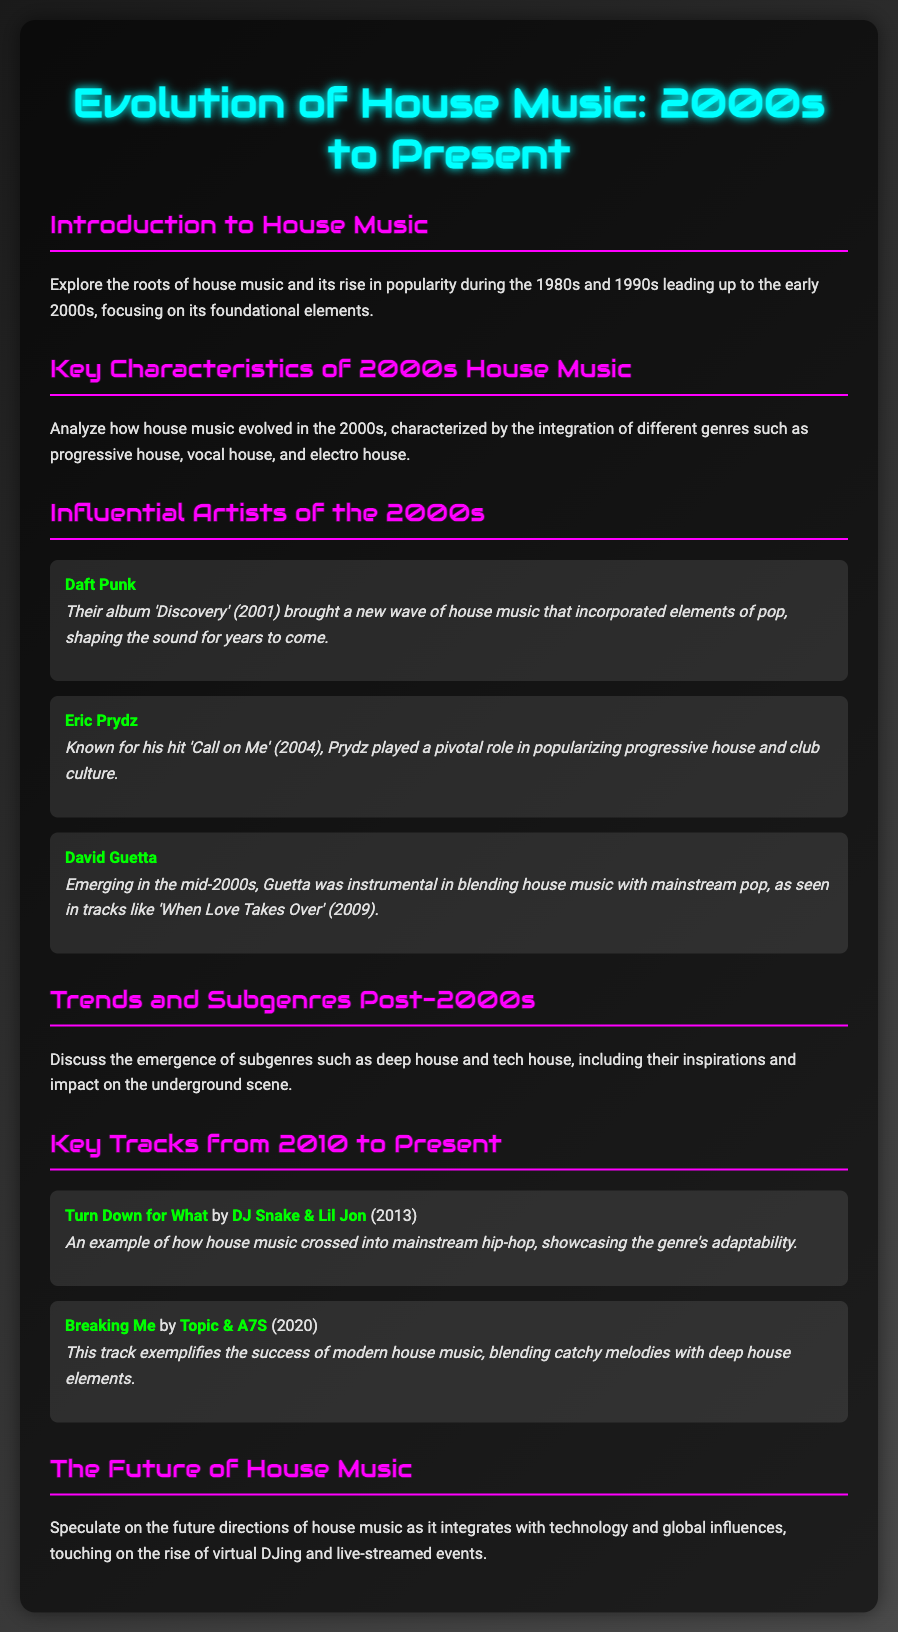what year was Daft Punk's album 'Discovery' released? The document states that Daft Punk's album 'Discovery' was released in 2001.
Answer: 2001 who is known for the hit 'Call on Me'? The document mentions that Eric Prydz is known for the hit 'Call on Me'.
Answer: Eric Prydz which subgenre of house music emerged post-2000s? The document discusses the emergence of deep house as a subgenre that developed post-2000s.
Answer: deep house what impact did David Guetta have on house music? The document explains that David Guetta blended house music with mainstream pop, particularly noted in the track 'When Love Takes Over'.
Answer: blended house with pop name a track by DJ Snake & Lil Jon. The document lists 'Turn Down for What' as a track by DJ Snake & Lil Jon.
Answer: Turn Down for What what does the document speculate about the future of house music? The document speculates on the integration of technology and global influences in the future of house music.
Answer: integration of technology in what year was the track 'Breaking Me' released? The document states that 'Breaking Me' was released in 2020.
Answer: 2020 which key characteristic defined house music in the 2000s? The document describes the integration of different genres as a key characteristic of house music in the 2000s.
Answer: integration of different genres 